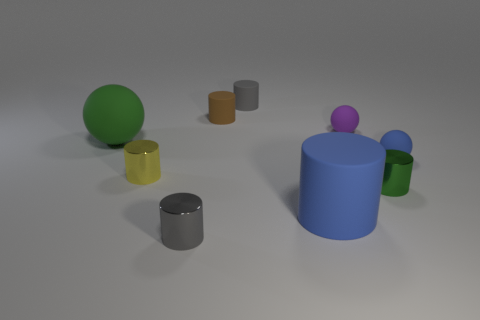Is the gray cylinder in front of the small green metal thing made of the same material as the tiny yellow cylinder?
Give a very brief answer. Yes. Are there fewer big green rubber spheres on the right side of the small green metal cylinder than large gray cubes?
Give a very brief answer. No. What number of matte things are cylinders or small purple spheres?
Your answer should be very brief. 4. Does the large matte ball have the same color as the large matte cylinder?
Your answer should be compact. No. Are there any other things that are the same color as the large matte cylinder?
Your answer should be compact. Yes. Is the shape of the large matte object right of the tiny gray matte thing the same as the big thing behind the green shiny cylinder?
Your response must be concise. No. What number of things are tiny purple things or small cylinders that are on the left side of the gray matte cylinder?
Your response must be concise. 4. What number of other objects are there of the same size as the gray shiny object?
Your answer should be compact. 6. Is the material of the big object that is to the right of the brown matte thing the same as the blue object that is behind the yellow metal object?
Keep it short and to the point. Yes. What number of rubber cylinders are in front of the large sphere?
Make the answer very short. 1. 